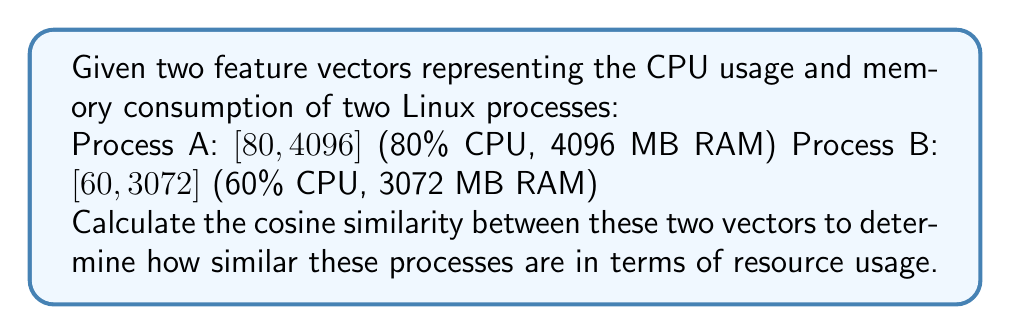Show me your answer to this math problem. To calculate the cosine similarity between two vectors, we use the formula:

$$\text{cosine similarity} = \frac{\mathbf{A} \cdot \mathbf{B}}{\|\mathbf{A}\| \|\mathbf{B}\|}$$

Where $\mathbf{A} \cdot \mathbf{B}$ is the dot product of the vectors, and $\|\mathbf{A}\|$ and $\|\mathbf{B}\|$ are the magnitudes of vectors A and B respectively.

Step 1: Calculate the dot product $\mathbf{A} \cdot \mathbf{B}$
$\mathbf{A} \cdot \mathbf{B} = (80 \times 60) + (4096 \times 3072) = 4800 + 12,582,912 = 12,587,712$

Step 2: Calculate the magnitude of vector A
$\|\mathbf{A}\| = \sqrt{80^2 + 4096^2} = \sqrt{6400 + 16,777,216} = \sqrt{16,783,616} = 4096.78$

Step 3: Calculate the magnitude of vector B
$\|\mathbf{B}\| = \sqrt{60^2 + 3072^2} = \sqrt{3600 + 9,437,184} = \sqrt{9,440,784} = 3072.58$

Step 4: Calculate the cosine similarity
$$\text{cosine similarity} = \frac{12,587,712}{4096.78 \times 3072.58} = \frac{12,587,712}{12,587,712.77} = 0.9999999$$
Answer: The cosine similarity between the two process vectors is approximately 0.9999999. 